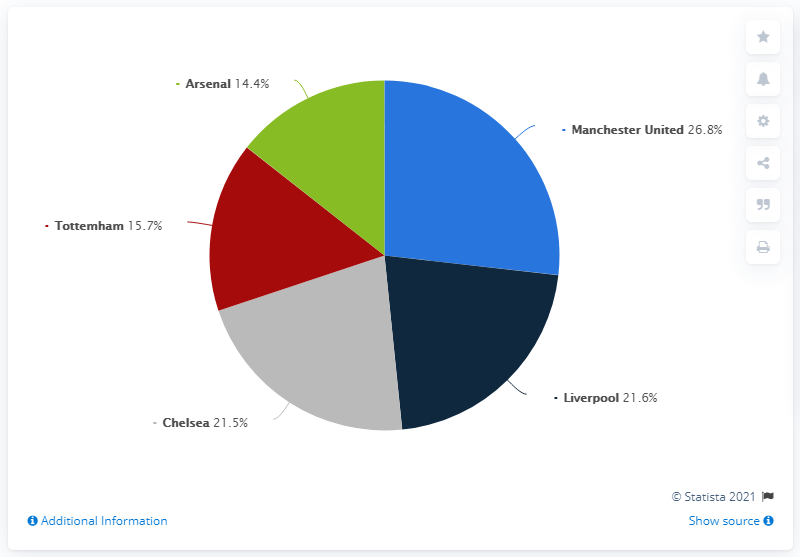Mention a couple of crucial points in this snapshot. Of the segments, only gray segment exceeds 20% except for those that have 2 segments. According to the data available as of July 2019, Arsenal generated the smallest share of sponsorship revenue among all the clubs included in the dataset. In July 2019, Manchester United generated 26.8% of its sponsorship revenue, according to the most recent available data. The smallest segment in the pie chart is green. 